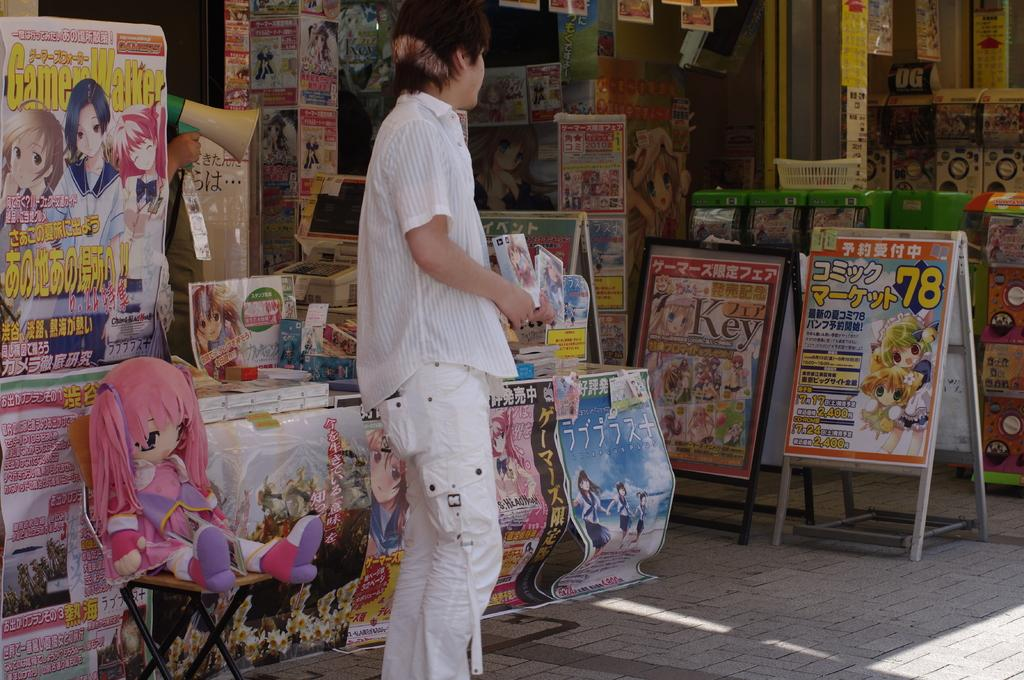<image>
Provide a brief description of the given image. A man in all white stands in front of Anime posters that say things such as GameWalker and other things in a foreign language. 